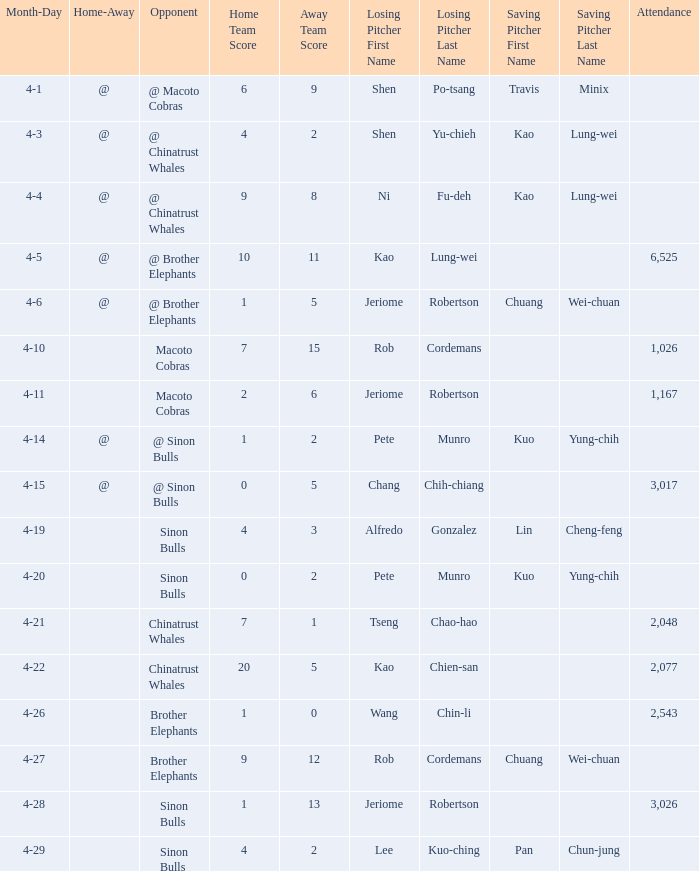Who earned the save in the game against the Sinon Bulls when Jeriome Robertson took the loss? ||3,026. 